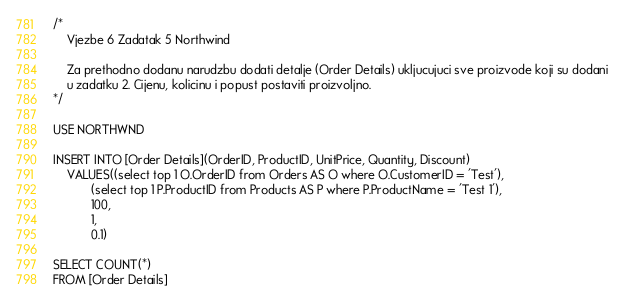<code> <loc_0><loc_0><loc_500><loc_500><_SQL_>/*
	Vjezbe 6 Zadatak 5 Northwind

	Za prethodno dodanu narudzbu dodati detalje (Order Details) ukljucujuci sve proizvode koji su dodani 
	u zadatku 2. Cijenu, kolicinu i popust postaviti proizvoljno. 
*/

USE NORTHWND

INSERT INTO [Order Details](OrderID, ProductID, UnitPrice, Quantity, Discount)
	VALUES((select top 1 O.OrderID from Orders AS O where O.CustomerID = 'Test'),
		   (select top 1 P.ProductID from Products AS P where P.ProductName = 'Test 1'),
		   100,
		   1,
		   0.1)

SELECT COUNT(*)
FROM [Order Details]</code> 